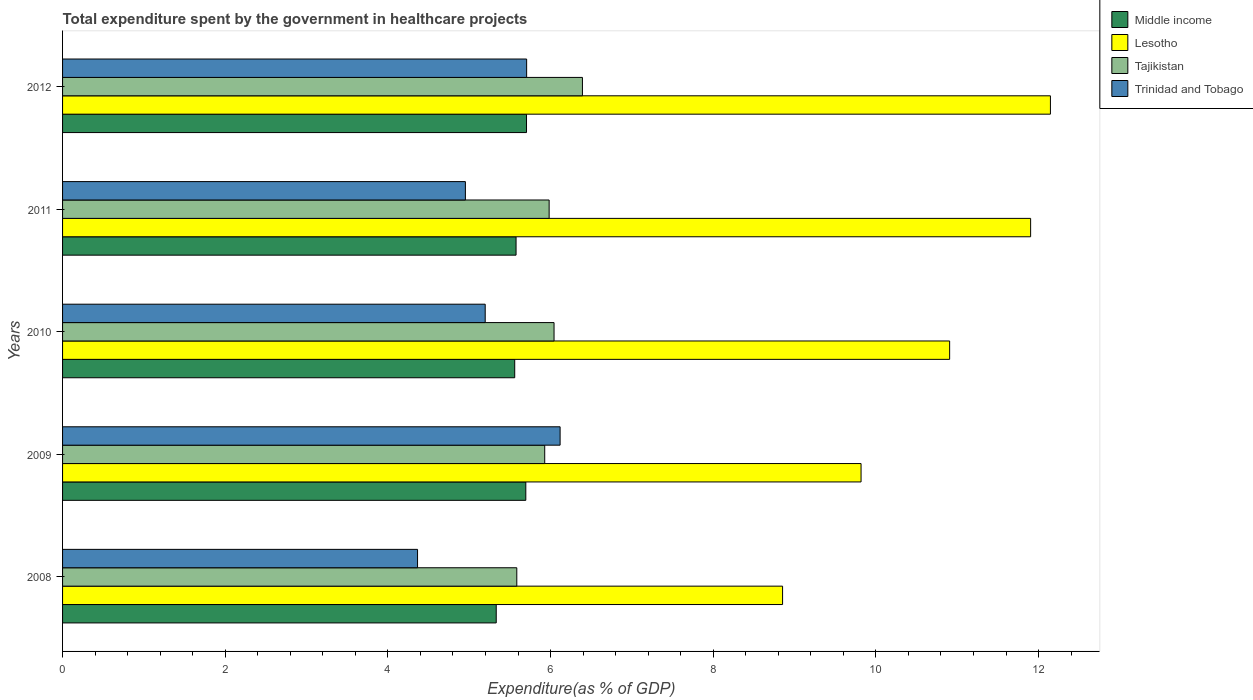How many groups of bars are there?
Offer a terse response. 5. Are the number of bars per tick equal to the number of legend labels?
Ensure brevity in your answer.  Yes. What is the total expenditure spent by the government in healthcare projects in Trinidad and Tobago in 2012?
Provide a short and direct response. 5.71. Across all years, what is the maximum total expenditure spent by the government in healthcare projects in Trinidad and Tobago?
Make the answer very short. 6.12. Across all years, what is the minimum total expenditure spent by the government in healthcare projects in Trinidad and Tobago?
Your answer should be compact. 4.36. In which year was the total expenditure spent by the government in healthcare projects in Middle income maximum?
Provide a succinct answer. 2012. In which year was the total expenditure spent by the government in healthcare projects in Tajikistan minimum?
Make the answer very short. 2008. What is the total total expenditure spent by the government in healthcare projects in Tajikistan in the graph?
Offer a very short reply. 29.93. What is the difference between the total expenditure spent by the government in healthcare projects in Lesotho in 2010 and that in 2011?
Your answer should be very brief. -1. What is the difference between the total expenditure spent by the government in healthcare projects in Trinidad and Tobago in 2010 and the total expenditure spent by the government in healthcare projects in Middle income in 2009?
Your response must be concise. -0.5. What is the average total expenditure spent by the government in healthcare projects in Middle income per year?
Provide a short and direct response. 5.57. In the year 2012, what is the difference between the total expenditure spent by the government in healthcare projects in Trinidad and Tobago and total expenditure spent by the government in healthcare projects in Lesotho?
Your response must be concise. -6.44. What is the ratio of the total expenditure spent by the government in healthcare projects in Tajikistan in 2009 to that in 2010?
Provide a short and direct response. 0.98. Is the total expenditure spent by the government in healthcare projects in Middle income in 2010 less than that in 2012?
Give a very brief answer. Yes. What is the difference between the highest and the second highest total expenditure spent by the government in healthcare projects in Tajikistan?
Give a very brief answer. 0.35. What is the difference between the highest and the lowest total expenditure spent by the government in healthcare projects in Lesotho?
Offer a terse response. 3.29. In how many years, is the total expenditure spent by the government in healthcare projects in Trinidad and Tobago greater than the average total expenditure spent by the government in healthcare projects in Trinidad and Tobago taken over all years?
Make the answer very short. 2. Is the sum of the total expenditure spent by the government in healthcare projects in Trinidad and Tobago in 2010 and 2011 greater than the maximum total expenditure spent by the government in healthcare projects in Middle income across all years?
Ensure brevity in your answer.  Yes. What does the 3rd bar from the top in 2011 represents?
Provide a succinct answer. Lesotho. What does the 3rd bar from the bottom in 2008 represents?
Offer a very short reply. Tajikistan. Is it the case that in every year, the sum of the total expenditure spent by the government in healthcare projects in Tajikistan and total expenditure spent by the government in healthcare projects in Lesotho is greater than the total expenditure spent by the government in healthcare projects in Trinidad and Tobago?
Your answer should be very brief. Yes. How many bars are there?
Provide a short and direct response. 20. How many years are there in the graph?
Make the answer very short. 5. What is the difference between two consecutive major ticks on the X-axis?
Provide a succinct answer. 2. Does the graph contain any zero values?
Keep it short and to the point. No. How many legend labels are there?
Offer a terse response. 4. What is the title of the graph?
Your response must be concise. Total expenditure spent by the government in healthcare projects. What is the label or title of the X-axis?
Make the answer very short. Expenditure(as % of GDP). What is the Expenditure(as % of GDP) of Middle income in 2008?
Provide a short and direct response. 5.33. What is the Expenditure(as % of GDP) in Lesotho in 2008?
Give a very brief answer. 8.85. What is the Expenditure(as % of GDP) of Tajikistan in 2008?
Make the answer very short. 5.58. What is the Expenditure(as % of GDP) of Trinidad and Tobago in 2008?
Make the answer very short. 4.36. What is the Expenditure(as % of GDP) in Middle income in 2009?
Offer a terse response. 5.7. What is the Expenditure(as % of GDP) of Lesotho in 2009?
Ensure brevity in your answer.  9.82. What is the Expenditure(as % of GDP) in Tajikistan in 2009?
Keep it short and to the point. 5.93. What is the Expenditure(as % of GDP) of Trinidad and Tobago in 2009?
Provide a short and direct response. 6.12. What is the Expenditure(as % of GDP) of Middle income in 2010?
Provide a short and direct response. 5.56. What is the Expenditure(as % of GDP) of Lesotho in 2010?
Make the answer very short. 10.91. What is the Expenditure(as % of GDP) in Tajikistan in 2010?
Make the answer very short. 6.04. What is the Expenditure(as % of GDP) of Trinidad and Tobago in 2010?
Provide a succinct answer. 5.2. What is the Expenditure(as % of GDP) of Middle income in 2011?
Give a very brief answer. 5.58. What is the Expenditure(as % of GDP) of Lesotho in 2011?
Ensure brevity in your answer.  11.9. What is the Expenditure(as % of GDP) in Tajikistan in 2011?
Give a very brief answer. 5.98. What is the Expenditure(as % of GDP) in Trinidad and Tobago in 2011?
Your answer should be compact. 4.95. What is the Expenditure(as % of GDP) of Middle income in 2012?
Keep it short and to the point. 5.7. What is the Expenditure(as % of GDP) of Lesotho in 2012?
Keep it short and to the point. 12.15. What is the Expenditure(as % of GDP) in Tajikistan in 2012?
Your response must be concise. 6.39. What is the Expenditure(as % of GDP) in Trinidad and Tobago in 2012?
Provide a short and direct response. 5.71. Across all years, what is the maximum Expenditure(as % of GDP) in Middle income?
Offer a terse response. 5.7. Across all years, what is the maximum Expenditure(as % of GDP) in Lesotho?
Your response must be concise. 12.15. Across all years, what is the maximum Expenditure(as % of GDP) in Tajikistan?
Make the answer very short. 6.39. Across all years, what is the maximum Expenditure(as % of GDP) of Trinidad and Tobago?
Offer a terse response. 6.12. Across all years, what is the minimum Expenditure(as % of GDP) of Middle income?
Keep it short and to the point. 5.33. Across all years, what is the minimum Expenditure(as % of GDP) of Lesotho?
Ensure brevity in your answer.  8.85. Across all years, what is the minimum Expenditure(as % of GDP) in Tajikistan?
Give a very brief answer. 5.58. Across all years, what is the minimum Expenditure(as % of GDP) of Trinidad and Tobago?
Keep it short and to the point. 4.36. What is the total Expenditure(as % of GDP) in Middle income in the graph?
Your response must be concise. 27.87. What is the total Expenditure(as % of GDP) of Lesotho in the graph?
Make the answer very short. 53.63. What is the total Expenditure(as % of GDP) in Tajikistan in the graph?
Offer a terse response. 29.93. What is the total Expenditure(as % of GDP) in Trinidad and Tobago in the graph?
Give a very brief answer. 26.34. What is the difference between the Expenditure(as % of GDP) in Middle income in 2008 and that in 2009?
Make the answer very short. -0.36. What is the difference between the Expenditure(as % of GDP) of Lesotho in 2008 and that in 2009?
Keep it short and to the point. -0.96. What is the difference between the Expenditure(as % of GDP) in Tajikistan in 2008 and that in 2009?
Provide a succinct answer. -0.34. What is the difference between the Expenditure(as % of GDP) in Trinidad and Tobago in 2008 and that in 2009?
Offer a terse response. -1.75. What is the difference between the Expenditure(as % of GDP) in Middle income in 2008 and that in 2010?
Your answer should be compact. -0.23. What is the difference between the Expenditure(as % of GDP) in Lesotho in 2008 and that in 2010?
Give a very brief answer. -2.05. What is the difference between the Expenditure(as % of GDP) in Tajikistan in 2008 and that in 2010?
Offer a terse response. -0.46. What is the difference between the Expenditure(as % of GDP) of Trinidad and Tobago in 2008 and that in 2010?
Provide a succinct answer. -0.83. What is the difference between the Expenditure(as % of GDP) in Middle income in 2008 and that in 2011?
Ensure brevity in your answer.  -0.24. What is the difference between the Expenditure(as % of GDP) in Lesotho in 2008 and that in 2011?
Keep it short and to the point. -3.05. What is the difference between the Expenditure(as % of GDP) of Tajikistan in 2008 and that in 2011?
Keep it short and to the point. -0.4. What is the difference between the Expenditure(as % of GDP) in Trinidad and Tobago in 2008 and that in 2011?
Make the answer very short. -0.59. What is the difference between the Expenditure(as % of GDP) of Middle income in 2008 and that in 2012?
Keep it short and to the point. -0.37. What is the difference between the Expenditure(as % of GDP) of Lesotho in 2008 and that in 2012?
Your answer should be compact. -3.29. What is the difference between the Expenditure(as % of GDP) of Tajikistan in 2008 and that in 2012?
Keep it short and to the point. -0.81. What is the difference between the Expenditure(as % of GDP) of Trinidad and Tobago in 2008 and that in 2012?
Provide a succinct answer. -1.34. What is the difference between the Expenditure(as % of GDP) of Middle income in 2009 and that in 2010?
Offer a very short reply. 0.14. What is the difference between the Expenditure(as % of GDP) in Lesotho in 2009 and that in 2010?
Keep it short and to the point. -1.09. What is the difference between the Expenditure(as % of GDP) in Tajikistan in 2009 and that in 2010?
Make the answer very short. -0.11. What is the difference between the Expenditure(as % of GDP) of Trinidad and Tobago in 2009 and that in 2010?
Your answer should be compact. 0.92. What is the difference between the Expenditure(as % of GDP) of Middle income in 2009 and that in 2011?
Make the answer very short. 0.12. What is the difference between the Expenditure(as % of GDP) in Lesotho in 2009 and that in 2011?
Keep it short and to the point. -2.08. What is the difference between the Expenditure(as % of GDP) of Tajikistan in 2009 and that in 2011?
Your response must be concise. -0.05. What is the difference between the Expenditure(as % of GDP) in Trinidad and Tobago in 2009 and that in 2011?
Your response must be concise. 1.16. What is the difference between the Expenditure(as % of GDP) in Middle income in 2009 and that in 2012?
Your answer should be very brief. -0.01. What is the difference between the Expenditure(as % of GDP) of Lesotho in 2009 and that in 2012?
Your answer should be very brief. -2.33. What is the difference between the Expenditure(as % of GDP) of Tajikistan in 2009 and that in 2012?
Your answer should be compact. -0.46. What is the difference between the Expenditure(as % of GDP) of Trinidad and Tobago in 2009 and that in 2012?
Your answer should be very brief. 0.41. What is the difference between the Expenditure(as % of GDP) of Middle income in 2010 and that in 2011?
Give a very brief answer. -0.02. What is the difference between the Expenditure(as % of GDP) of Lesotho in 2010 and that in 2011?
Offer a terse response. -1. What is the difference between the Expenditure(as % of GDP) in Tajikistan in 2010 and that in 2011?
Provide a succinct answer. 0.06. What is the difference between the Expenditure(as % of GDP) of Trinidad and Tobago in 2010 and that in 2011?
Make the answer very short. 0.24. What is the difference between the Expenditure(as % of GDP) of Middle income in 2010 and that in 2012?
Keep it short and to the point. -0.14. What is the difference between the Expenditure(as % of GDP) of Lesotho in 2010 and that in 2012?
Your answer should be very brief. -1.24. What is the difference between the Expenditure(as % of GDP) in Tajikistan in 2010 and that in 2012?
Give a very brief answer. -0.35. What is the difference between the Expenditure(as % of GDP) in Trinidad and Tobago in 2010 and that in 2012?
Ensure brevity in your answer.  -0.51. What is the difference between the Expenditure(as % of GDP) in Middle income in 2011 and that in 2012?
Keep it short and to the point. -0.13. What is the difference between the Expenditure(as % of GDP) of Lesotho in 2011 and that in 2012?
Make the answer very short. -0.24. What is the difference between the Expenditure(as % of GDP) of Tajikistan in 2011 and that in 2012?
Your response must be concise. -0.41. What is the difference between the Expenditure(as % of GDP) of Trinidad and Tobago in 2011 and that in 2012?
Your answer should be very brief. -0.75. What is the difference between the Expenditure(as % of GDP) of Middle income in 2008 and the Expenditure(as % of GDP) of Lesotho in 2009?
Your answer should be very brief. -4.49. What is the difference between the Expenditure(as % of GDP) of Middle income in 2008 and the Expenditure(as % of GDP) of Tajikistan in 2009?
Make the answer very short. -0.6. What is the difference between the Expenditure(as % of GDP) in Middle income in 2008 and the Expenditure(as % of GDP) in Trinidad and Tobago in 2009?
Your answer should be compact. -0.79. What is the difference between the Expenditure(as % of GDP) in Lesotho in 2008 and the Expenditure(as % of GDP) in Tajikistan in 2009?
Your answer should be very brief. 2.92. What is the difference between the Expenditure(as % of GDP) in Lesotho in 2008 and the Expenditure(as % of GDP) in Trinidad and Tobago in 2009?
Give a very brief answer. 2.74. What is the difference between the Expenditure(as % of GDP) of Tajikistan in 2008 and the Expenditure(as % of GDP) of Trinidad and Tobago in 2009?
Your response must be concise. -0.53. What is the difference between the Expenditure(as % of GDP) in Middle income in 2008 and the Expenditure(as % of GDP) in Lesotho in 2010?
Give a very brief answer. -5.57. What is the difference between the Expenditure(as % of GDP) in Middle income in 2008 and the Expenditure(as % of GDP) in Tajikistan in 2010?
Your answer should be compact. -0.71. What is the difference between the Expenditure(as % of GDP) of Middle income in 2008 and the Expenditure(as % of GDP) of Trinidad and Tobago in 2010?
Ensure brevity in your answer.  0.14. What is the difference between the Expenditure(as % of GDP) in Lesotho in 2008 and the Expenditure(as % of GDP) in Tajikistan in 2010?
Offer a very short reply. 2.81. What is the difference between the Expenditure(as % of GDP) of Lesotho in 2008 and the Expenditure(as % of GDP) of Trinidad and Tobago in 2010?
Keep it short and to the point. 3.66. What is the difference between the Expenditure(as % of GDP) in Tajikistan in 2008 and the Expenditure(as % of GDP) in Trinidad and Tobago in 2010?
Make the answer very short. 0.39. What is the difference between the Expenditure(as % of GDP) in Middle income in 2008 and the Expenditure(as % of GDP) in Lesotho in 2011?
Your response must be concise. -6.57. What is the difference between the Expenditure(as % of GDP) in Middle income in 2008 and the Expenditure(as % of GDP) in Tajikistan in 2011?
Offer a very short reply. -0.65. What is the difference between the Expenditure(as % of GDP) of Middle income in 2008 and the Expenditure(as % of GDP) of Trinidad and Tobago in 2011?
Your answer should be very brief. 0.38. What is the difference between the Expenditure(as % of GDP) of Lesotho in 2008 and the Expenditure(as % of GDP) of Tajikistan in 2011?
Provide a succinct answer. 2.87. What is the difference between the Expenditure(as % of GDP) in Lesotho in 2008 and the Expenditure(as % of GDP) in Trinidad and Tobago in 2011?
Your answer should be very brief. 3.9. What is the difference between the Expenditure(as % of GDP) of Tajikistan in 2008 and the Expenditure(as % of GDP) of Trinidad and Tobago in 2011?
Make the answer very short. 0.63. What is the difference between the Expenditure(as % of GDP) in Middle income in 2008 and the Expenditure(as % of GDP) in Lesotho in 2012?
Ensure brevity in your answer.  -6.81. What is the difference between the Expenditure(as % of GDP) of Middle income in 2008 and the Expenditure(as % of GDP) of Tajikistan in 2012?
Provide a short and direct response. -1.06. What is the difference between the Expenditure(as % of GDP) of Middle income in 2008 and the Expenditure(as % of GDP) of Trinidad and Tobago in 2012?
Your response must be concise. -0.37. What is the difference between the Expenditure(as % of GDP) of Lesotho in 2008 and the Expenditure(as % of GDP) of Tajikistan in 2012?
Your response must be concise. 2.46. What is the difference between the Expenditure(as % of GDP) in Lesotho in 2008 and the Expenditure(as % of GDP) in Trinidad and Tobago in 2012?
Keep it short and to the point. 3.15. What is the difference between the Expenditure(as % of GDP) of Tajikistan in 2008 and the Expenditure(as % of GDP) of Trinidad and Tobago in 2012?
Offer a very short reply. -0.12. What is the difference between the Expenditure(as % of GDP) in Middle income in 2009 and the Expenditure(as % of GDP) in Lesotho in 2010?
Ensure brevity in your answer.  -5.21. What is the difference between the Expenditure(as % of GDP) in Middle income in 2009 and the Expenditure(as % of GDP) in Tajikistan in 2010?
Offer a terse response. -0.35. What is the difference between the Expenditure(as % of GDP) of Middle income in 2009 and the Expenditure(as % of GDP) of Trinidad and Tobago in 2010?
Offer a very short reply. 0.5. What is the difference between the Expenditure(as % of GDP) in Lesotho in 2009 and the Expenditure(as % of GDP) in Tajikistan in 2010?
Your answer should be compact. 3.77. What is the difference between the Expenditure(as % of GDP) of Lesotho in 2009 and the Expenditure(as % of GDP) of Trinidad and Tobago in 2010?
Your answer should be compact. 4.62. What is the difference between the Expenditure(as % of GDP) in Tajikistan in 2009 and the Expenditure(as % of GDP) in Trinidad and Tobago in 2010?
Give a very brief answer. 0.73. What is the difference between the Expenditure(as % of GDP) in Middle income in 2009 and the Expenditure(as % of GDP) in Lesotho in 2011?
Offer a terse response. -6.21. What is the difference between the Expenditure(as % of GDP) of Middle income in 2009 and the Expenditure(as % of GDP) of Tajikistan in 2011?
Your response must be concise. -0.29. What is the difference between the Expenditure(as % of GDP) in Middle income in 2009 and the Expenditure(as % of GDP) in Trinidad and Tobago in 2011?
Offer a terse response. 0.74. What is the difference between the Expenditure(as % of GDP) in Lesotho in 2009 and the Expenditure(as % of GDP) in Tajikistan in 2011?
Offer a very short reply. 3.84. What is the difference between the Expenditure(as % of GDP) in Lesotho in 2009 and the Expenditure(as % of GDP) in Trinidad and Tobago in 2011?
Your answer should be very brief. 4.86. What is the difference between the Expenditure(as % of GDP) in Tajikistan in 2009 and the Expenditure(as % of GDP) in Trinidad and Tobago in 2011?
Your response must be concise. 0.98. What is the difference between the Expenditure(as % of GDP) of Middle income in 2009 and the Expenditure(as % of GDP) of Lesotho in 2012?
Offer a terse response. -6.45. What is the difference between the Expenditure(as % of GDP) of Middle income in 2009 and the Expenditure(as % of GDP) of Tajikistan in 2012?
Make the answer very short. -0.7. What is the difference between the Expenditure(as % of GDP) in Middle income in 2009 and the Expenditure(as % of GDP) in Trinidad and Tobago in 2012?
Provide a succinct answer. -0.01. What is the difference between the Expenditure(as % of GDP) in Lesotho in 2009 and the Expenditure(as % of GDP) in Tajikistan in 2012?
Ensure brevity in your answer.  3.43. What is the difference between the Expenditure(as % of GDP) in Lesotho in 2009 and the Expenditure(as % of GDP) in Trinidad and Tobago in 2012?
Keep it short and to the point. 4.11. What is the difference between the Expenditure(as % of GDP) in Tajikistan in 2009 and the Expenditure(as % of GDP) in Trinidad and Tobago in 2012?
Your answer should be compact. 0.22. What is the difference between the Expenditure(as % of GDP) in Middle income in 2010 and the Expenditure(as % of GDP) in Lesotho in 2011?
Your response must be concise. -6.34. What is the difference between the Expenditure(as % of GDP) of Middle income in 2010 and the Expenditure(as % of GDP) of Tajikistan in 2011?
Make the answer very short. -0.42. What is the difference between the Expenditure(as % of GDP) in Middle income in 2010 and the Expenditure(as % of GDP) in Trinidad and Tobago in 2011?
Your response must be concise. 0.61. What is the difference between the Expenditure(as % of GDP) of Lesotho in 2010 and the Expenditure(as % of GDP) of Tajikistan in 2011?
Offer a terse response. 4.92. What is the difference between the Expenditure(as % of GDP) of Lesotho in 2010 and the Expenditure(as % of GDP) of Trinidad and Tobago in 2011?
Your answer should be very brief. 5.95. What is the difference between the Expenditure(as % of GDP) of Tajikistan in 2010 and the Expenditure(as % of GDP) of Trinidad and Tobago in 2011?
Your answer should be compact. 1.09. What is the difference between the Expenditure(as % of GDP) in Middle income in 2010 and the Expenditure(as % of GDP) in Lesotho in 2012?
Give a very brief answer. -6.59. What is the difference between the Expenditure(as % of GDP) of Middle income in 2010 and the Expenditure(as % of GDP) of Tajikistan in 2012?
Your answer should be very brief. -0.83. What is the difference between the Expenditure(as % of GDP) of Middle income in 2010 and the Expenditure(as % of GDP) of Trinidad and Tobago in 2012?
Keep it short and to the point. -0.15. What is the difference between the Expenditure(as % of GDP) in Lesotho in 2010 and the Expenditure(as % of GDP) in Tajikistan in 2012?
Make the answer very short. 4.51. What is the difference between the Expenditure(as % of GDP) of Lesotho in 2010 and the Expenditure(as % of GDP) of Trinidad and Tobago in 2012?
Ensure brevity in your answer.  5.2. What is the difference between the Expenditure(as % of GDP) of Tajikistan in 2010 and the Expenditure(as % of GDP) of Trinidad and Tobago in 2012?
Keep it short and to the point. 0.34. What is the difference between the Expenditure(as % of GDP) in Middle income in 2011 and the Expenditure(as % of GDP) in Lesotho in 2012?
Offer a terse response. -6.57. What is the difference between the Expenditure(as % of GDP) of Middle income in 2011 and the Expenditure(as % of GDP) of Tajikistan in 2012?
Your answer should be compact. -0.82. What is the difference between the Expenditure(as % of GDP) in Middle income in 2011 and the Expenditure(as % of GDP) in Trinidad and Tobago in 2012?
Your answer should be compact. -0.13. What is the difference between the Expenditure(as % of GDP) of Lesotho in 2011 and the Expenditure(as % of GDP) of Tajikistan in 2012?
Keep it short and to the point. 5.51. What is the difference between the Expenditure(as % of GDP) of Lesotho in 2011 and the Expenditure(as % of GDP) of Trinidad and Tobago in 2012?
Offer a terse response. 6.2. What is the difference between the Expenditure(as % of GDP) of Tajikistan in 2011 and the Expenditure(as % of GDP) of Trinidad and Tobago in 2012?
Your answer should be very brief. 0.28. What is the average Expenditure(as % of GDP) in Middle income per year?
Keep it short and to the point. 5.57. What is the average Expenditure(as % of GDP) of Lesotho per year?
Your answer should be very brief. 10.72. What is the average Expenditure(as % of GDP) of Tajikistan per year?
Your answer should be compact. 5.99. What is the average Expenditure(as % of GDP) in Trinidad and Tobago per year?
Keep it short and to the point. 5.27. In the year 2008, what is the difference between the Expenditure(as % of GDP) of Middle income and Expenditure(as % of GDP) of Lesotho?
Keep it short and to the point. -3.52. In the year 2008, what is the difference between the Expenditure(as % of GDP) in Middle income and Expenditure(as % of GDP) in Tajikistan?
Your answer should be very brief. -0.25. In the year 2008, what is the difference between the Expenditure(as % of GDP) in Middle income and Expenditure(as % of GDP) in Trinidad and Tobago?
Provide a succinct answer. 0.97. In the year 2008, what is the difference between the Expenditure(as % of GDP) of Lesotho and Expenditure(as % of GDP) of Tajikistan?
Offer a very short reply. 3.27. In the year 2008, what is the difference between the Expenditure(as % of GDP) of Lesotho and Expenditure(as % of GDP) of Trinidad and Tobago?
Your answer should be very brief. 4.49. In the year 2008, what is the difference between the Expenditure(as % of GDP) in Tajikistan and Expenditure(as % of GDP) in Trinidad and Tobago?
Your answer should be very brief. 1.22. In the year 2009, what is the difference between the Expenditure(as % of GDP) of Middle income and Expenditure(as % of GDP) of Lesotho?
Your answer should be very brief. -4.12. In the year 2009, what is the difference between the Expenditure(as % of GDP) in Middle income and Expenditure(as % of GDP) in Tajikistan?
Give a very brief answer. -0.23. In the year 2009, what is the difference between the Expenditure(as % of GDP) in Middle income and Expenditure(as % of GDP) in Trinidad and Tobago?
Your answer should be compact. -0.42. In the year 2009, what is the difference between the Expenditure(as % of GDP) of Lesotho and Expenditure(as % of GDP) of Tajikistan?
Provide a succinct answer. 3.89. In the year 2009, what is the difference between the Expenditure(as % of GDP) in Lesotho and Expenditure(as % of GDP) in Trinidad and Tobago?
Keep it short and to the point. 3.7. In the year 2009, what is the difference between the Expenditure(as % of GDP) of Tajikistan and Expenditure(as % of GDP) of Trinidad and Tobago?
Offer a terse response. -0.19. In the year 2010, what is the difference between the Expenditure(as % of GDP) in Middle income and Expenditure(as % of GDP) in Lesotho?
Your answer should be compact. -5.35. In the year 2010, what is the difference between the Expenditure(as % of GDP) in Middle income and Expenditure(as % of GDP) in Tajikistan?
Your answer should be very brief. -0.48. In the year 2010, what is the difference between the Expenditure(as % of GDP) of Middle income and Expenditure(as % of GDP) of Trinidad and Tobago?
Keep it short and to the point. 0.36. In the year 2010, what is the difference between the Expenditure(as % of GDP) in Lesotho and Expenditure(as % of GDP) in Tajikistan?
Offer a very short reply. 4.86. In the year 2010, what is the difference between the Expenditure(as % of GDP) in Lesotho and Expenditure(as % of GDP) in Trinidad and Tobago?
Ensure brevity in your answer.  5.71. In the year 2010, what is the difference between the Expenditure(as % of GDP) in Tajikistan and Expenditure(as % of GDP) in Trinidad and Tobago?
Ensure brevity in your answer.  0.85. In the year 2011, what is the difference between the Expenditure(as % of GDP) of Middle income and Expenditure(as % of GDP) of Lesotho?
Ensure brevity in your answer.  -6.33. In the year 2011, what is the difference between the Expenditure(as % of GDP) of Middle income and Expenditure(as % of GDP) of Tajikistan?
Your response must be concise. -0.41. In the year 2011, what is the difference between the Expenditure(as % of GDP) of Middle income and Expenditure(as % of GDP) of Trinidad and Tobago?
Your answer should be very brief. 0.62. In the year 2011, what is the difference between the Expenditure(as % of GDP) in Lesotho and Expenditure(as % of GDP) in Tajikistan?
Ensure brevity in your answer.  5.92. In the year 2011, what is the difference between the Expenditure(as % of GDP) of Lesotho and Expenditure(as % of GDP) of Trinidad and Tobago?
Keep it short and to the point. 6.95. In the year 2011, what is the difference between the Expenditure(as % of GDP) in Tajikistan and Expenditure(as % of GDP) in Trinidad and Tobago?
Keep it short and to the point. 1.03. In the year 2012, what is the difference between the Expenditure(as % of GDP) of Middle income and Expenditure(as % of GDP) of Lesotho?
Your answer should be very brief. -6.44. In the year 2012, what is the difference between the Expenditure(as % of GDP) in Middle income and Expenditure(as % of GDP) in Tajikistan?
Provide a short and direct response. -0.69. In the year 2012, what is the difference between the Expenditure(as % of GDP) in Middle income and Expenditure(as % of GDP) in Trinidad and Tobago?
Your answer should be very brief. -0. In the year 2012, what is the difference between the Expenditure(as % of GDP) in Lesotho and Expenditure(as % of GDP) in Tajikistan?
Provide a short and direct response. 5.75. In the year 2012, what is the difference between the Expenditure(as % of GDP) in Lesotho and Expenditure(as % of GDP) in Trinidad and Tobago?
Ensure brevity in your answer.  6.44. In the year 2012, what is the difference between the Expenditure(as % of GDP) of Tajikistan and Expenditure(as % of GDP) of Trinidad and Tobago?
Provide a succinct answer. 0.69. What is the ratio of the Expenditure(as % of GDP) in Middle income in 2008 to that in 2009?
Your response must be concise. 0.94. What is the ratio of the Expenditure(as % of GDP) in Lesotho in 2008 to that in 2009?
Your answer should be very brief. 0.9. What is the ratio of the Expenditure(as % of GDP) in Tajikistan in 2008 to that in 2009?
Give a very brief answer. 0.94. What is the ratio of the Expenditure(as % of GDP) of Trinidad and Tobago in 2008 to that in 2009?
Make the answer very short. 0.71. What is the ratio of the Expenditure(as % of GDP) of Middle income in 2008 to that in 2010?
Ensure brevity in your answer.  0.96. What is the ratio of the Expenditure(as % of GDP) in Lesotho in 2008 to that in 2010?
Ensure brevity in your answer.  0.81. What is the ratio of the Expenditure(as % of GDP) in Tajikistan in 2008 to that in 2010?
Offer a terse response. 0.92. What is the ratio of the Expenditure(as % of GDP) of Trinidad and Tobago in 2008 to that in 2010?
Ensure brevity in your answer.  0.84. What is the ratio of the Expenditure(as % of GDP) of Middle income in 2008 to that in 2011?
Your answer should be very brief. 0.96. What is the ratio of the Expenditure(as % of GDP) in Lesotho in 2008 to that in 2011?
Offer a very short reply. 0.74. What is the ratio of the Expenditure(as % of GDP) in Tajikistan in 2008 to that in 2011?
Provide a succinct answer. 0.93. What is the ratio of the Expenditure(as % of GDP) of Trinidad and Tobago in 2008 to that in 2011?
Give a very brief answer. 0.88. What is the ratio of the Expenditure(as % of GDP) of Middle income in 2008 to that in 2012?
Offer a terse response. 0.93. What is the ratio of the Expenditure(as % of GDP) in Lesotho in 2008 to that in 2012?
Your response must be concise. 0.73. What is the ratio of the Expenditure(as % of GDP) of Tajikistan in 2008 to that in 2012?
Your answer should be very brief. 0.87. What is the ratio of the Expenditure(as % of GDP) of Trinidad and Tobago in 2008 to that in 2012?
Ensure brevity in your answer.  0.76. What is the ratio of the Expenditure(as % of GDP) of Middle income in 2009 to that in 2010?
Your answer should be very brief. 1.02. What is the ratio of the Expenditure(as % of GDP) of Lesotho in 2009 to that in 2010?
Make the answer very short. 0.9. What is the ratio of the Expenditure(as % of GDP) in Trinidad and Tobago in 2009 to that in 2010?
Ensure brevity in your answer.  1.18. What is the ratio of the Expenditure(as % of GDP) in Middle income in 2009 to that in 2011?
Make the answer very short. 1.02. What is the ratio of the Expenditure(as % of GDP) of Lesotho in 2009 to that in 2011?
Make the answer very short. 0.82. What is the ratio of the Expenditure(as % of GDP) in Tajikistan in 2009 to that in 2011?
Your answer should be very brief. 0.99. What is the ratio of the Expenditure(as % of GDP) of Trinidad and Tobago in 2009 to that in 2011?
Make the answer very short. 1.24. What is the ratio of the Expenditure(as % of GDP) in Lesotho in 2009 to that in 2012?
Your response must be concise. 0.81. What is the ratio of the Expenditure(as % of GDP) in Tajikistan in 2009 to that in 2012?
Your answer should be compact. 0.93. What is the ratio of the Expenditure(as % of GDP) of Trinidad and Tobago in 2009 to that in 2012?
Provide a succinct answer. 1.07. What is the ratio of the Expenditure(as % of GDP) in Middle income in 2010 to that in 2011?
Keep it short and to the point. 1. What is the ratio of the Expenditure(as % of GDP) of Lesotho in 2010 to that in 2011?
Make the answer very short. 0.92. What is the ratio of the Expenditure(as % of GDP) in Trinidad and Tobago in 2010 to that in 2011?
Provide a succinct answer. 1.05. What is the ratio of the Expenditure(as % of GDP) in Middle income in 2010 to that in 2012?
Keep it short and to the point. 0.97. What is the ratio of the Expenditure(as % of GDP) of Lesotho in 2010 to that in 2012?
Your answer should be very brief. 0.9. What is the ratio of the Expenditure(as % of GDP) in Tajikistan in 2010 to that in 2012?
Offer a very short reply. 0.95. What is the ratio of the Expenditure(as % of GDP) in Trinidad and Tobago in 2010 to that in 2012?
Keep it short and to the point. 0.91. What is the ratio of the Expenditure(as % of GDP) of Middle income in 2011 to that in 2012?
Provide a succinct answer. 0.98. What is the ratio of the Expenditure(as % of GDP) of Lesotho in 2011 to that in 2012?
Keep it short and to the point. 0.98. What is the ratio of the Expenditure(as % of GDP) in Tajikistan in 2011 to that in 2012?
Your answer should be very brief. 0.94. What is the ratio of the Expenditure(as % of GDP) in Trinidad and Tobago in 2011 to that in 2012?
Your response must be concise. 0.87. What is the difference between the highest and the second highest Expenditure(as % of GDP) of Middle income?
Your answer should be very brief. 0.01. What is the difference between the highest and the second highest Expenditure(as % of GDP) in Lesotho?
Your answer should be very brief. 0.24. What is the difference between the highest and the second highest Expenditure(as % of GDP) in Tajikistan?
Ensure brevity in your answer.  0.35. What is the difference between the highest and the second highest Expenditure(as % of GDP) of Trinidad and Tobago?
Ensure brevity in your answer.  0.41. What is the difference between the highest and the lowest Expenditure(as % of GDP) in Middle income?
Ensure brevity in your answer.  0.37. What is the difference between the highest and the lowest Expenditure(as % of GDP) in Lesotho?
Offer a very short reply. 3.29. What is the difference between the highest and the lowest Expenditure(as % of GDP) of Tajikistan?
Keep it short and to the point. 0.81. What is the difference between the highest and the lowest Expenditure(as % of GDP) of Trinidad and Tobago?
Offer a very short reply. 1.75. 